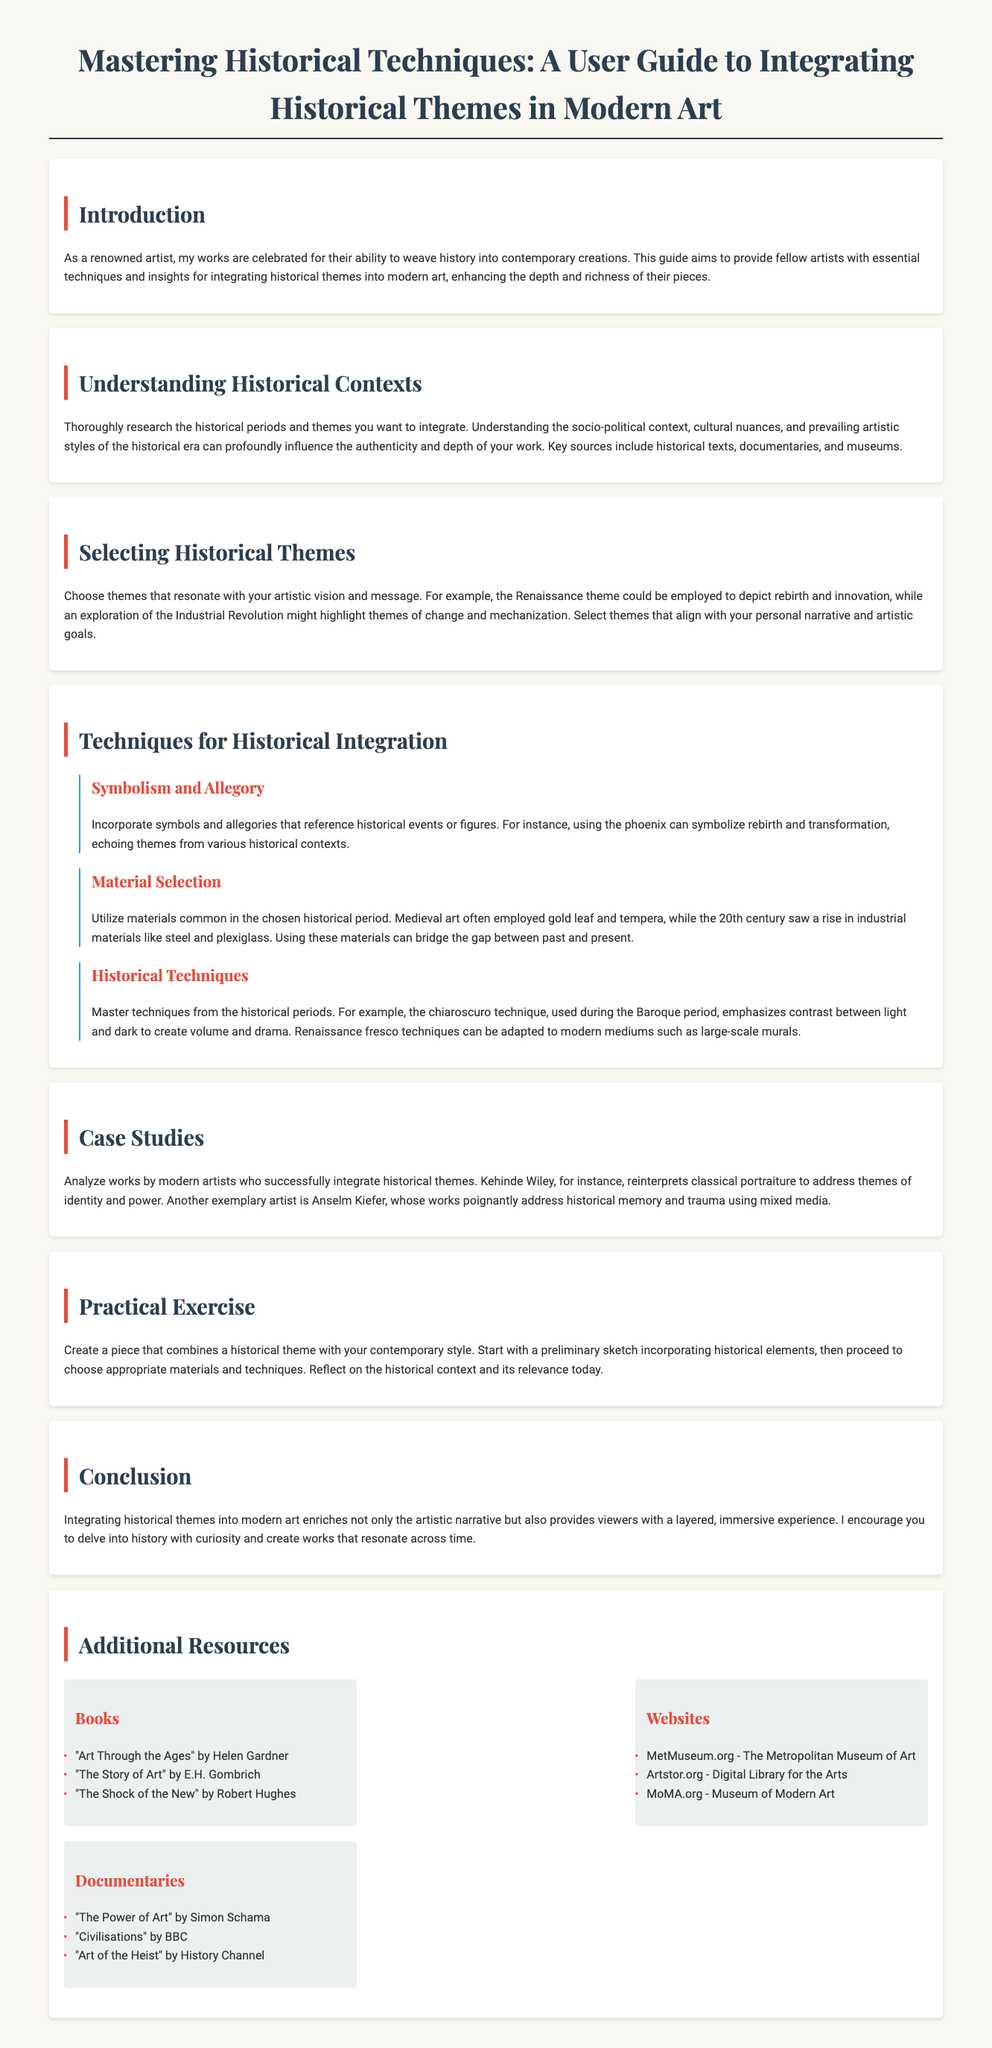What is the title of the guide? The title is stated at the beginning of the document and clearly reads "Mastering Historical Techniques: A User Guide to Integrating Historical Themes in Modern Art."
Answer: Mastering Historical Techniques: A User Guide to Integrating Historical Themes in Modern Art Who is the author of the guide? The introduction mentions that it is written by a renowned artist.
Answer: A renowned artist What historical technique is emphasized for its dramatic effect? The document mentions chiaroscuro as a technique that emphasizes contrast to create volume and drama.
Answer: Chiaroscuro Which materials are suggested for the Medieval art period? The guide specifies that Medieval art often employed gold leaf and tempera as common materials.
Answer: Gold leaf and tempera Name one modern artist referenced in the case studies. The document lists Kehinde Wiley as one of the artists who successfully integrates historical themes.
Answer: Kehinde Wiley What is the focus of the practical exercise? The practical exercise encourages creating a piece that combines a historical theme with contemporary style.
Answer: Combining a historical theme with contemporary style What type of resources are provided at the end of the guide? The additional resources section includes books, websites, and documentaries related to art history and techniques.
Answer: Books, websites, and documentaries Which historical period could be employed to depict rebirth? The guide suggests using the Renaissance theme to depict rebirth and innovation.
Answer: Renaissance What is the purpose of understanding socio-political contexts? The document indicates that understanding socio-political contexts profoundly influences the authenticity and depth of the art.
Answer: To influence authenticity and depth 